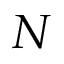Convert formula to latex. <formula><loc_0><loc_0><loc_500><loc_500>N</formula> 